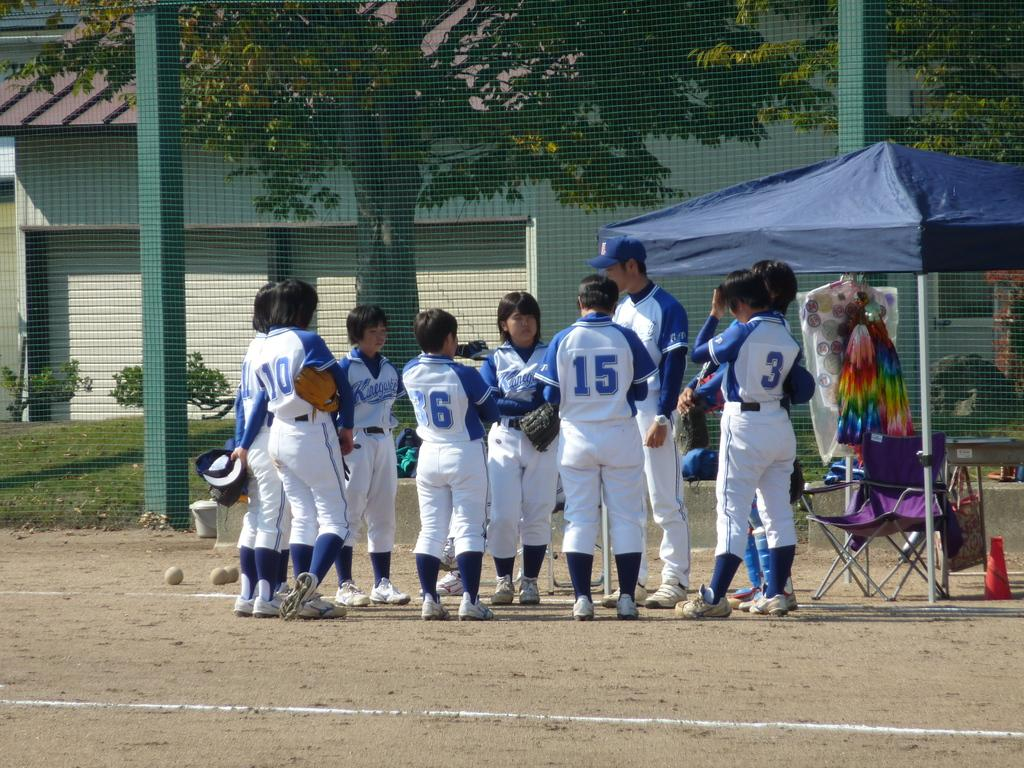<image>
Summarize the visual content of the image. a young group of babseball players including number 6, 15, and 3 talking with their coach 